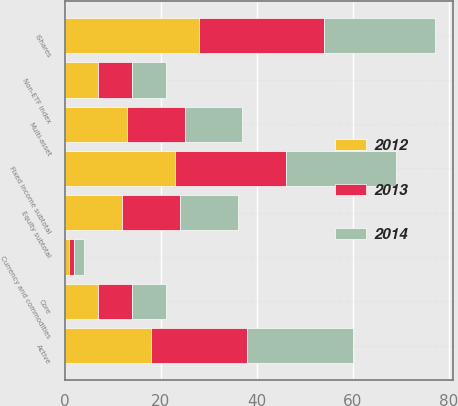Convert chart to OTSL. <chart><loc_0><loc_0><loc_500><loc_500><stacked_bar_chart><ecel><fcel>Active<fcel>iShares<fcel>Non-ETF index<fcel>Equity subtotal<fcel>Fixed income subtotal<fcel>Multi-asset<fcel>Core<fcel>Currency and commodities<nl><fcel>2012<fcel>18<fcel>28<fcel>7<fcel>12<fcel>23<fcel>13<fcel>7<fcel>1<nl><fcel>2013<fcel>20<fcel>26<fcel>7<fcel>12<fcel>23<fcel>12<fcel>7<fcel>1<nl><fcel>2014<fcel>22<fcel>23<fcel>7<fcel>12<fcel>23<fcel>12<fcel>7<fcel>2<nl></chart> 